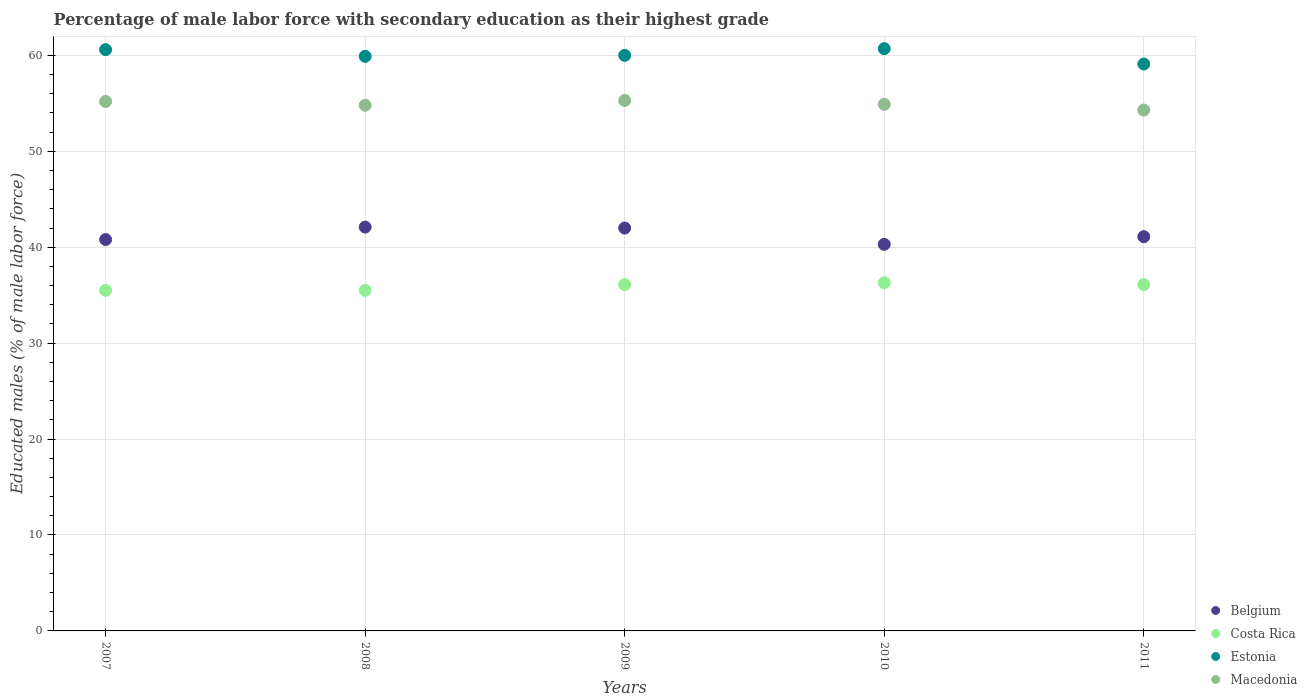How many different coloured dotlines are there?
Your answer should be compact. 4. What is the percentage of male labor force with secondary education in Estonia in 2011?
Give a very brief answer. 59.1. Across all years, what is the maximum percentage of male labor force with secondary education in Macedonia?
Your response must be concise. 55.3. Across all years, what is the minimum percentage of male labor force with secondary education in Costa Rica?
Provide a succinct answer. 35.5. In which year was the percentage of male labor force with secondary education in Macedonia minimum?
Your answer should be compact. 2011. What is the total percentage of male labor force with secondary education in Estonia in the graph?
Your response must be concise. 300.3. What is the difference between the percentage of male labor force with secondary education in Belgium in 2009 and that in 2010?
Make the answer very short. 1.7. What is the difference between the percentage of male labor force with secondary education in Belgium in 2007 and the percentage of male labor force with secondary education in Estonia in 2009?
Provide a short and direct response. -19.2. What is the average percentage of male labor force with secondary education in Estonia per year?
Offer a terse response. 60.06. In the year 2010, what is the difference between the percentage of male labor force with secondary education in Costa Rica and percentage of male labor force with secondary education in Estonia?
Offer a terse response. -24.4. In how many years, is the percentage of male labor force with secondary education in Costa Rica greater than 58 %?
Offer a very short reply. 0. What is the ratio of the percentage of male labor force with secondary education in Belgium in 2007 to that in 2009?
Ensure brevity in your answer.  0.97. Is the percentage of male labor force with secondary education in Costa Rica in 2009 less than that in 2011?
Make the answer very short. No. What is the difference between the highest and the second highest percentage of male labor force with secondary education in Belgium?
Your answer should be compact. 0.1. What is the difference between the highest and the lowest percentage of male labor force with secondary education in Costa Rica?
Provide a short and direct response. 0.8. Is it the case that in every year, the sum of the percentage of male labor force with secondary education in Estonia and percentage of male labor force with secondary education in Belgium  is greater than the percentage of male labor force with secondary education in Costa Rica?
Give a very brief answer. Yes. Is the percentage of male labor force with secondary education in Costa Rica strictly greater than the percentage of male labor force with secondary education in Estonia over the years?
Provide a short and direct response. No. Is the percentage of male labor force with secondary education in Belgium strictly less than the percentage of male labor force with secondary education in Estonia over the years?
Provide a succinct answer. Yes. How many dotlines are there?
Ensure brevity in your answer.  4. How many years are there in the graph?
Your answer should be compact. 5. What is the title of the graph?
Give a very brief answer. Percentage of male labor force with secondary education as their highest grade. What is the label or title of the Y-axis?
Offer a terse response. Educated males (% of male labor force). What is the Educated males (% of male labor force) in Belgium in 2007?
Your answer should be compact. 40.8. What is the Educated males (% of male labor force) of Costa Rica in 2007?
Your answer should be compact. 35.5. What is the Educated males (% of male labor force) of Estonia in 2007?
Provide a succinct answer. 60.6. What is the Educated males (% of male labor force) in Macedonia in 2007?
Your response must be concise. 55.2. What is the Educated males (% of male labor force) in Belgium in 2008?
Provide a short and direct response. 42.1. What is the Educated males (% of male labor force) of Costa Rica in 2008?
Provide a succinct answer. 35.5. What is the Educated males (% of male labor force) of Estonia in 2008?
Offer a very short reply. 59.9. What is the Educated males (% of male labor force) of Macedonia in 2008?
Ensure brevity in your answer.  54.8. What is the Educated males (% of male labor force) of Belgium in 2009?
Provide a succinct answer. 42. What is the Educated males (% of male labor force) of Costa Rica in 2009?
Offer a very short reply. 36.1. What is the Educated males (% of male labor force) of Macedonia in 2009?
Ensure brevity in your answer.  55.3. What is the Educated males (% of male labor force) in Belgium in 2010?
Your response must be concise. 40.3. What is the Educated males (% of male labor force) in Costa Rica in 2010?
Your answer should be compact. 36.3. What is the Educated males (% of male labor force) in Estonia in 2010?
Your response must be concise. 60.7. What is the Educated males (% of male labor force) of Macedonia in 2010?
Keep it short and to the point. 54.9. What is the Educated males (% of male labor force) of Belgium in 2011?
Give a very brief answer. 41.1. What is the Educated males (% of male labor force) in Costa Rica in 2011?
Give a very brief answer. 36.1. What is the Educated males (% of male labor force) of Estonia in 2011?
Make the answer very short. 59.1. What is the Educated males (% of male labor force) in Macedonia in 2011?
Offer a very short reply. 54.3. Across all years, what is the maximum Educated males (% of male labor force) in Belgium?
Your answer should be compact. 42.1. Across all years, what is the maximum Educated males (% of male labor force) in Costa Rica?
Provide a succinct answer. 36.3. Across all years, what is the maximum Educated males (% of male labor force) of Estonia?
Your answer should be compact. 60.7. Across all years, what is the maximum Educated males (% of male labor force) in Macedonia?
Provide a succinct answer. 55.3. Across all years, what is the minimum Educated males (% of male labor force) in Belgium?
Offer a terse response. 40.3. Across all years, what is the minimum Educated males (% of male labor force) in Costa Rica?
Make the answer very short. 35.5. Across all years, what is the minimum Educated males (% of male labor force) in Estonia?
Make the answer very short. 59.1. Across all years, what is the minimum Educated males (% of male labor force) in Macedonia?
Your answer should be very brief. 54.3. What is the total Educated males (% of male labor force) in Belgium in the graph?
Your answer should be very brief. 206.3. What is the total Educated males (% of male labor force) of Costa Rica in the graph?
Your response must be concise. 179.5. What is the total Educated males (% of male labor force) of Estonia in the graph?
Keep it short and to the point. 300.3. What is the total Educated males (% of male labor force) in Macedonia in the graph?
Offer a terse response. 274.5. What is the difference between the Educated males (% of male labor force) in Belgium in 2007 and that in 2008?
Offer a very short reply. -1.3. What is the difference between the Educated males (% of male labor force) of Costa Rica in 2007 and that in 2008?
Your answer should be compact. 0. What is the difference between the Educated males (% of male labor force) of Estonia in 2007 and that in 2008?
Offer a terse response. 0.7. What is the difference between the Educated males (% of male labor force) in Macedonia in 2007 and that in 2008?
Your answer should be compact. 0.4. What is the difference between the Educated males (% of male labor force) in Belgium in 2007 and that in 2009?
Your response must be concise. -1.2. What is the difference between the Educated males (% of male labor force) in Estonia in 2007 and that in 2009?
Your answer should be very brief. 0.6. What is the difference between the Educated males (% of male labor force) of Macedonia in 2007 and that in 2009?
Ensure brevity in your answer.  -0.1. What is the difference between the Educated males (% of male labor force) in Estonia in 2007 and that in 2011?
Offer a very short reply. 1.5. What is the difference between the Educated males (% of male labor force) of Macedonia in 2007 and that in 2011?
Make the answer very short. 0.9. What is the difference between the Educated males (% of male labor force) of Belgium in 2008 and that in 2009?
Ensure brevity in your answer.  0.1. What is the difference between the Educated males (% of male labor force) of Estonia in 2008 and that in 2009?
Provide a succinct answer. -0.1. What is the difference between the Educated males (% of male labor force) of Belgium in 2008 and that in 2010?
Offer a very short reply. 1.8. What is the difference between the Educated males (% of male labor force) of Macedonia in 2008 and that in 2010?
Give a very brief answer. -0.1. What is the difference between the Educated males (% of male labor force) in Belgium in 2008 and that in 2011?
Your response must be concise. 1. What is the difference between the Educated males (% of male labor force) in Belgium in 2009 and that in 2010?
Provide a short and direct response. 1.7. What is the difference between the Educated males (% of male labor force) in Costa Rica in 2009 and that in 2010?
Provide a short and direct response. -0.2. What is the difference between the Educated males (% of male labor force) of Estonia in 2009 and that in 2010?
Offer a very short reply. -0.7. What is the difference between the Educated males (% of male labor force) of Belgium in 2009 and that in 2011?
Your answer should be compact. 0.9. What is the difference between the Educated males (% of male labor force) in Costa Rica in 2009 and that in 2011?
Provide a short and direct response. 0. What is the difference between the Educated males (% of male labor force) in Macedonia in 2009 and that in 2011?
Offer a terse response. 1. What is the difference between the Educated males (% of male labor force) in Estonia in 2010 and that in 2011?
Provide a succinct answer. 1.6. What is the difference between the Educated males (% of male labor force) in Belgium in 2007 and the Educated males (% of male labor force) in Costa Rica in 2008?
Offer a terse response. 5.3. What is the difference between the Educated males (% of male labor force) of Belgium in 2007 and the Educated males (% of male labor force) of Estonia in 2008?
Give a very brief answer. -19.1. What is the difference between the Educated males (% of male labor force) of Costa Rica in 2007 and the Educated males (% of male labor force) of Estonia in 2008?
Your answer should be compact. -24.4. What is the difference between the Educated males (% of male labor force) of Costa Rica in 2007 and the Educated males (% of male labor force) of Macedonia in 2008?
Your answer should be compact. -19.3. What is the difference between the Educated males (% of male labor force) of Belgium in 2007 and the Educated males (% of male labor force) of Costa Rica in 2009?
Provide a short and direct response. 4.7. What is the difference between the Educated males (% of male labor force) in Belgium in 2007 and the Educated males (% of male labor force) in Estonia in 2009?
Ensure brevity in your answer.  -19.2. What is the difference between the Educated males (% of male labor force) in Costa Rica in 2007 and the Educated males (% of male labor force) in Estonia in 2009?
Provide a short and direct response. -24.5. What is the difference between the Educated males (% of male labor force) in Costa Rica in 2007 and the Educated males (% of male labor force) in Macedonia in 2009?
Your answer should be very brief. -19.8. What is the difference between the Educated males (% of male labor force) in Estonia in 2007 and the Educated males (% of male labor force) in Macedonia in 2009?
Provide a succinct answer. 5.3. What is the difference between the Educated males (% of male labor force) in Belgium in 2007 and the Educated males (% of male labor force) in Estonia in 2010?
Offer a terse response. -19.9. What is the difference between the Educated males (% of male labor force) of Belgium in 2007 and the Educated males (% of male labor force) of Macedonia in 2010?
Provide a short and direct response. -14.1. What is the difference between the Educated males (% of male labor force) of Costa Rica in 2007 and the Educated males (% of male labor force) of Estonia in 2010?
Your answer should be compact. -25.2. What is the difference between the Educated males (% of male labor force) in Costa Rica in 2007 and the Educated males (% of male labor force) in Macedonia in 2010?
Provide a succinct answer. -19.4. What is the difference between the Educated males (% of male labor force) in Estonia in 2007 and the Educated males (% of male labor force) in Macedonia in 2010?
Give a very brief answer. 5.7. What is the difference between the Educated males (% of male labor force) of Belgium in 2007 and the Educated males (% of male labor force) of Costa Rica in 2011?
Your answer should be compact. 4.7. What is the difference between the Educated males (% of male labor force) of Belgium in 2007 and the Educated males (% of male labor force) of Estonia in 2011?
Offer a terse response. -18.3. What is the difference between the Educated males (% of male labor force) of Belgium in 2007 and the Educated males (% of male labor force) of Macedonia in 2011?
Your answer should be compact. -13.5. What is the difference between the Educated males (% of male labor force) of Costa Rica in 2007 and the Educated males (% of male labor force) of Estonia in 2011?
Provide a succinct answer. -23.6. What is the difference between the Educated males (% of male labor force) in Costa Rica in 2007 and the Educated males (% of male labor force) in Macedonia in 2011?
Ensure brevity in your answer.  -18.8. What is the difference between the Educated males (% of male labor force) of Estonia in 2007 and the Educated males (% of male labor force) of Macedonia in 2011?
Offer a terse response. 6.3. What is the difference between the Educated males (% of male labor force) in Belgium in 2008 and the Educated males (% of male labor force) in Costa Rica in 2009?
Offer a very short reply. 6. What is the difference between the Educated males (% of male labor force) in Belgium in 2008 and the Educated males (% of male labor force) in Estonia in 2009?
Provide a succinct answer. -17.9. What is the difference between the Educated males (% of male labor force) of Costa Rica in 2008 and the Educated males (% of male labor force) of Estonia in 2009?
Ensure brevity in your answer.  -24.5. What is the difference between the Educated males (% of male labor force) of Costa Rica in 2008 and the Educated males (% of male labor force) of Macedonia in 2009?
Your answer should be compact. -19.8. What is the difference between the Educated males (% of male labor force) of Estonia in 2008 and the Educated males (% of male labor force) of Macedonia in 2009?
Offer a terse response. 4.6. What is the difference between the Educated males (% of male labor force) of Belgium in 2008 and the Educated males (% of male labor force) of Costa Rica in 2010?
Provide a short and direct response. 5.8. What is the difference between the Educated males (% of male labor force) in Belgium in 2008 and the Educated males (% of male labor force) in Estonia in 2010?
Provide a succinct answer. -18.6. What is the difference between the Educated males (% of male labor force) in Belgium in 2008 and the Educated males (% of male labor force) in Macedonia in 2010?
Ensure brevity in your answer.  -12.8. What is the difference between the Educated males (% of male labor force) in Costa Rica in 2008 and the Educated males (% of male labor force) in Estonia in 2010?
Offer a very short reply. -25.2. What is the difference between the Educated males (% of male labor force) in Costa Rica in 2008 and the Educated males (% of male labor force) in Macedonia in 2010?
Provide a succinct answer. -19.4. What is the difference between the Educated males (% of male labor force) of Belgium in 2008 and the Educated males (% of male labor force) of Costa Rica in 2011?
Your answer should be very brief. 6. What is the difference between the Educated males (% of male labor force) of Belgium in 2008 and the Educated males (% of male labor force) of Estonia in 2011?
Keep it short and to the point. -17. What is the difference between the Educated males (% of male labor force) in Belgium in 2008 and the Educated males (% of male labor force) in Macedonia in 2011?
Your response must be concise. -12.2. What is the difference between the Educated males (% of male labor force) in Costa Rica in 2008 and the Educated males (% of male labor force) in Estonia in 2011?
Your answer should be very brief. -23.6. What is the difference between the Educated males (% of male labor force) in Costa Rica in 2008 and the Educated males (% of male labor force) in Macedonia in 2011?
Your answer should be compact. -18.8. What is the difference between the Educated males (% of male labor force) of Belgium in 2009 and the Educated males (% of male labor force) of Estonia in 2010?
Provide a succinct answer. -18.7. What is the difference between the Educated males (% of male labor force) of Belgium in 2009 and the Educated males (% of male labor force) of Macedonia in 2010?
Ensure brevity in your answer.  -12.9. What is the difference between the Educated males (% of male labor force) of Costa Rica in 2009 and the Educated males (% of male labor force) of Estonia in 2010?
Your response must be concise. -24.6. What is the difference between the Educated males (% of male labor force) in Costa Rica in 2009 and the Educated males (% of male labor force) in Macedonia in 2010?
Offer a very short reply. -18.8. What is the difference between the Educated males (% of male labor force) of Belgium in 2009 and the Educated males (% of male labor force) of Estonia in 2011?
Offer a very short reply. -17.1. What is the difference between the Educated males (% of male labor force) of Costa Rica in 2009 and the Educated males (% of male labor force) of Macedonia in 2011?
Your answer should be compact. -18.2. What is the difference between the Educated males (% of male labor force) of Belgium in 2010 and the Educated males (% of male labor force) of Estonia in 2011?
Offer a terse response. -18.8. What is the difference between the Educated males (% of male labor force) of Belgium in 2010 and the Educated males (% of male labor force) of Macedonia in 2011?
Your answer should be compact. -14. What is the difference between the Educated males (% of male labor force) in Costa Rica in 2010 and the Educated males (% of male labor force) in Estonia in 2011?
Offer a very short reply. -22.8. What is the average Educated males (% of male labor force) of Belgium per year?
Your answer should be compact. 41.26. What is the average Educated males (% of male labor force) of Costa Rica per year?
Make the answer very short. 35.9. What is the average Educated males (% of male labor force) in Estonia per year?
Your answer should be very brief. 60.06. What is the average Educated males (% of male labor force) in Macedonia per year?
Offer a very short reply. 54.9. In the year 2007, what is the difference between the Educated males (% of male labor force) in Belgium and Educated males (% of male labor force) in Costa Rica?
Offer a very short reply. 5.3. In the year 2007, what is the difference between the Educated males (% of male labor force) in Belgium and Educated males (% of male labor force) in Estonia?
Provide a succinct answer. -19.8. In the year 2007, what is the difference between the Educated males (% of male labor force) of Belgium and Educated males (% of male labor force) of Macedonia?
Your response must be concise. -14.4. In the year 2007, what is the difference between the Educated males (% of male labor force) in Costa Rica and Educated males (% of male labor force) in Estonia?
Offer a terse response. -25.1. In the year 2007, what is the difference between the Educated males (% of male labor force) in Costa Rica and Educated males (% of male labor force) in Macedonia?
Provide a succinct answer. -19.7. In the year 2008, what is the difference between the Educated males (% of male labor force) in Belgium and Educated males (% of male labor force) in Costa Rica?
Ensure brevity in your answer.  6.6. In the year 2008, what is the difference between the Educated males (% of male labor force) of Belgium and Educated males (% of male labor force) of Estonia?
Keep it short and to the point. -17.8. In the year 2008, what is the difference between the Educated males (% of male labor force) in Belgium and Educated males (% of male labor force) in Macedonia?
Provide a succinct answer. -12.7. In the year 2008, what is the difference between the Educated males (% of male labor force) of Costa Rica and Educated males (% of male labor force) of Estonia?
Ensure brevity in your answer.  -24.4. In the year 2008, what is the difference between the Educated males (% of male labor force) in Costa Rica and Educated males (% of male labor force) in Macedonia?
Your response must be concise. -19.3. In the year 2008, what is the difference between the Educated males (% of male labor force) in Estonia and Educated males (% of male labor force) in Macedonia?
Make the answer very short. 5.1. In the year 2009, what is the difference between the Educated males (% of male labor force) in Belgium and Educated males (% of male labor force) in Costa Rica?
Provide a short and direct response. 5.9. In the year 2009, what is the difference between the Educated males (% of male labor force) in Belgium and Educated males (% of male labor force) in Macedonia?
Keep it short and to the point. -13.3. In the year 2009, what is the difference between the Educated males (% of male labor force) in Costa Rica and Educated males (% of male labor force) in Estonia?
Keep it short and to the point. -23.9. In the year 2009, what is the difference between the Educated males (% of male labor force) in Costa Rica and Educated males (% of male labor force) in Macedonia?
Provide a succinct answer. -19.2. In the year 2009, what is the difference between the Educated males (% of male labor force) of Estonia and Educated males (% of male labor force) of Macedonia?
Give a very brief answer. 4.7. In the year 2010, what is the difference between the Educated males (% of male labor force) of Belgium and Educated males (% of male labor force) of Estonia?
Your answer should be compact. -20.4. In the year 2010, what is the difference between the Educated males (% of male labor force) in Belgium and Educated males (% of male labor force) in Macedonia?
Offer a very short reply. -14.6. In the year 2010, what is the difference between the Educated males (% of male labor force) of Costa Rica and Educated males (% of male labor force) of Estonia?
Provide a succinct answer. -24.4. In the year 2010, what is the difference between the Educated males (% of male labor force) in Costa Rica and Educated males (% of male labor force) in Macedonia?
Your response must be concise. -18.6. In the year 2010, what is the difference between the Educated males (% of male labor force) of Estonia and Educated males (% of male labor force) of Macedonia?
Offer a very short reply. 5.8. In the year 2011, what is the difference between the Educated males (% of male labor force) of Belgium and Educated males (% of male labor force) of Macedonia?
Offer a very short reply. -13.2. In the year 2011, what is the difference between the Educated males (% of male labor force) of Costa Rica and Educated males (% of male labor force) of Estonia?
Give a very brief answer. -23. In the year 2011, what is the difference between the Educated males (% of male labor force) in Costa Rica and Educated males (% of male labor force) in Macedonia?
Give a very brief answer. -18.2. In the year 2011, what is the difference between the Educated males (% of male labor force) of Estonia and Educated males (% of male labor force) of Macedonia?
Your response must be concise. 4.8. What is the ratio of the Educated males (% of male labor force) in Belgium in 2007 to that in 2008?
Give a very brief answer. 0.97. What is the ratio of the Educated males (% of male labor force) of Costa Rica in 2007 to that in 2008?
Ensure brevity in your answer.  1. What is the ratio of the Educated males (% of male labor force) in Estonia in 2007 to that in 2008?
Ensure brevity in your answer.  1.01. What is the ratio of the Educated males (% of male labor force) of Macedonia in 2007 to that in 2008?
Keep it short and to the point. 1.01. What is the ratio of the Educated males (% of male labor force) in Belgium in 2007 to that in 2009?
Offer a terse response. 0.97. What is the ratio of the Educated males (% of male labor force) in Costa Rica in 2007 to that in 2009?
Give a very brief answer. 0.98. What is the ratio of the Educated males (% of male labor force) in Estonia in 2007 to that in 2009?
Ensure brevity in your answer.  1.01. What is the ratio of the Educated males (% of male labor force) of Macedonia in 2007 to that in 2009?
Give a very brief answer. 1. What is the ratio of the Educated males (% of male labor force) in Belgium in 2007 to that in 2010?
Your answer should be very brief. 1.01. What is the ratio of the Educated males (% of male labor force) of Estonia in 2007 to that in 2010?
Ensure brevity in your answer.  1. What is the ratio of the Educated males (% of male labor force) of Macedonia in 2007 to that in 2010?
Provide a short and direct response. 1.01. What is the ratio of the Educated males (% of male labor force) of Belgium in 2007 to that in 2011?
Your answer should be compact. 0.99. What is the ratio of the Educated males (% of male labor force) of Costa Rica in 2007 to that in 2011?
Your answer should be compact. 0.98. What is the ratio of the Educated males (% of male labor force) in Estonia in 2007 to that in 2011?
Keep it short and to the point. 1.03. What is the ratio of the Educated males (% of male labor force) in Macedonia in 2007 to that in 2011?
Offer a terse response. 1.02. What is the ratio of the Educated males (% of male labor force) in Costa Rica in 2008 to that in 2009?
Provide a succinct answer. 0.98. What is the ratio of the Educated males (% of male labor force) of Macedonia in 2008 to that in 2009?
Your answer should be compact. 0.99. What is the ratio of the Educated males (% of male labor force) of Belgium in 2008 to that in 2010?
Your answer should be compact. 1.04. What is the ratio of the Educated males (% of male labor force) of Costa Rica in 2008 to that in 2010?
Your answer should be compact. 0.98. What is the ratio of the Educated males (% of male labor force) in Macedonia in 2008 to that in 2010?
Keep it short and to the point. 1. What is the ratio of the Educated males (% of male labor force) in Belgium in 2008 to that in 2011?
Give a very brief answer. 1.02. What is the ratio of the Educated males (% of male labor force) in Costa Rica in 2008 to that in 2011?
Your answer should be compact. 0.98. What is the ratio of the Educated males (% of male labor force) of Estonia in 2008 to that in 2011?
Your answer should be very brief. 1.01. What is the ratio of the Educated males (% of male labor force) in Macedonia in 2008 to that in 2011?
Ensure brevity in your answer.  1.01. What is the ratio of the Educated males (% of male labor force) in Belgium in 2009 to that in 2010?
Offer a very short reply. 1.04. What is the ratio of the Educated males (% of male labor force) of Estonia in 2009 to that in 2010?
Offer a terse response. 0.99. What is the ratio of the Educated males (% of male labor force) of Macedonia in 2009 to that in 2010?
Give a very brief answer. 1.01. What is the ratio of the Educated males (% of male labor force) in Belgium in 2009 to that in 2011?
Your answer should be compact. 1.02. What is the ratio of the Educated males (% of male labor force) in Estonia in 2009 to that in 2011?
Give a very brief answer. 1.02. What is the ratio of the Educated males (% of male labor force) in Macedonia in 2009 to that in 2011?
Provide a short and direct response. 1.02. What is the ratio of the Educated males (% of male labor force) of Belgium in 2010 to that in 2011?
Provide a succinct answer. 0.98. What is the ratio of the Educated males (% of male labor force) of Estonia in 2010 to that in 2011?
Your answer should be compact. 1.03. What is the ratio of the Educated males (% of male labor force) in Macedonia in 2010 to that in 2011?
Give a very brief answer. 1.01. What is the difference between the highest and the second highest Educated males (% of male labor force) of Costa Rica?
Your answer should be very brief. 0.2. What is the difference between the highest and the second highest Educated males (% of male labor force) of Estonia?
Your answer should be very brief. 0.1. What is the difference between the highest and the lowest Educated males (% of male labor force) in Costa Rica?
Give a very brief answer. 0.8. What is the difference between the highest and the lowest Educated males (% of male labor force) in Estonia?
Offer a terse response. 1.6. What is the difference between the highest and the lowest Educated males (% of male labor force) of Macedonia?
Your response must be concise. 1. 